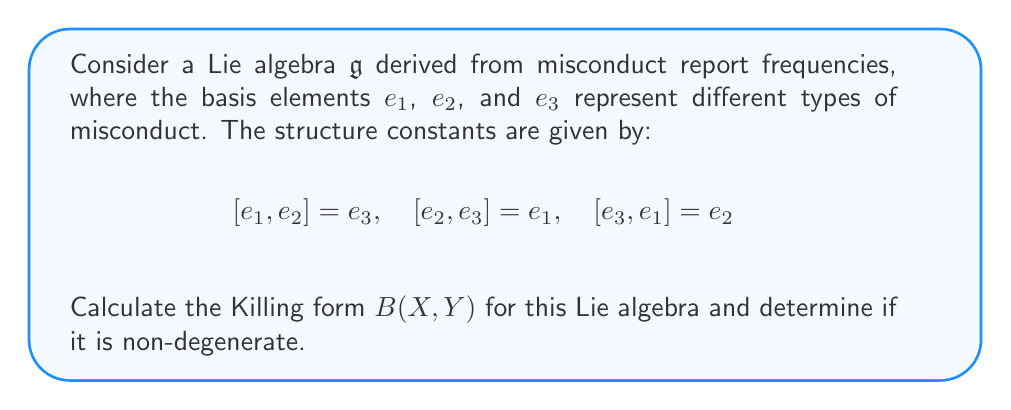Can you answer this question? To calculate the Killing form for this Lie algebra, we follow these steps:

1) The Killing form is defined as $B(X, Y) = \text{tr}(\text{ad}(X) \circ \text{ad}(Y))$, where $\text{ad}(X)$ is the adjoint representation of $X$.

2) We need to calculate the matrix representation of $\text{ad}(e_i)$ for each basis element:

   For $\text{ad}(e_1)$:
   $[e_1, e_2] = e_3 \implies (0,0,1)$
   $[e_1, e_3] = -e_2 \implies (0,-1,0)$
   
   $$\text{ad}(e_1) = \begin{pmatrix}
   0 & 0 & 0 \\
   0 & 0 & -1 \\
   0 & 1 & 0
   \end{pmatrix}$$

   Similarly,
   $$\text{ad}(e_2) = \begin{pmatrix}
   0 & 0 & 1 \\
   0 & 0 & 0 \\
   -1 & 0 & 0
   \end{pmatrix}$$

   $$\text{ad}(e_3) = \begin{pmatrix}
   0 & -1 & 0 \\
   1 & 0 & 0 \\
   0 & 0 & 0
   \end{pmatrix}$$

3) Now, we calculate $B(e_i, e_j)$ for all pairs:

   $B(e_1, e_1) = \text{tr}(\text{ad}(e_1) \circ \text{ad}(e_1)) = -2$
   $B(e_2, e_2) = \text{tr}(\text{ad}(e_2) \circ \text{ad}(e_2)) = -2$
   $B(e_3, e_3) = \text{tr}(\text{ad}(e_3) \circ \text{ad}(e_3)) = -2$

   $B(e_1, e_2) = B(e_2, e_1) = \text{tr}(\text{ad}(e_1) \circ \text{ad}(e_2)) = 0$
   $B(e_1, e_3) = B(e_3, e_1) = \text{tr}(\text{ad}(e_1) \circ \text{ad}(e_3)) = 0$
   $B(e_2, e_3) = B(e_3, e_2) = \text{tr}(\text{ad}(e_2) \circ \text{ad}(e_3)) = 0$

4) The Killing form matrix is:

   $$B = \begin{pmatrix}
   -2 & 0 & 0 \\
   0 & -2 & 0 \\
   0 & 0 & -2
   \end{pmatrix}$$

5) To determine if it's non-degenerate, we calculate the determinant:

   $\det(B) = (-2)^3 = -8 \neq 0$

   Since the determinant is non-zero, the Killing form is non-degenerate.
Answer: The Killing form for the given Lie algebra is:

$$B = \begin{pmatrix}
-2 & 0 & 0 \\
0 & -2 & 0 \\
0 & 0 & -2
\end{pmatrix}$$

The Killing form is non-degenerate. 